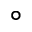Convert formula to latex. <formula><loc_0><loc_0><loc_500><loc_500>^ { \circ }</formula> 